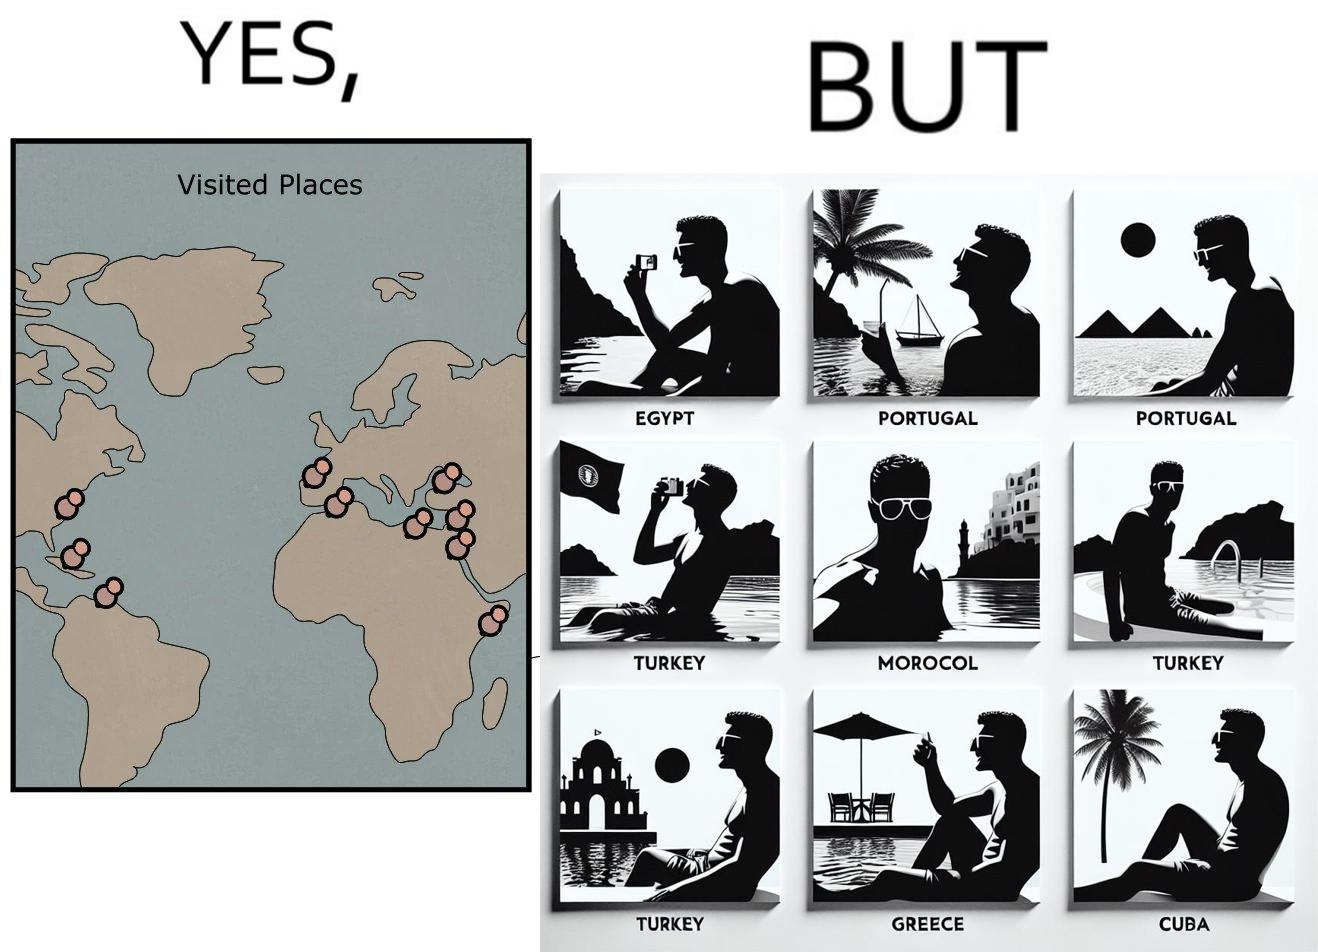What is shown in this image? The image is satirical because while the man has visited all the place marked on the map, he only seems to have swam in pools in all these differnt countries and has not actually seen these places. 